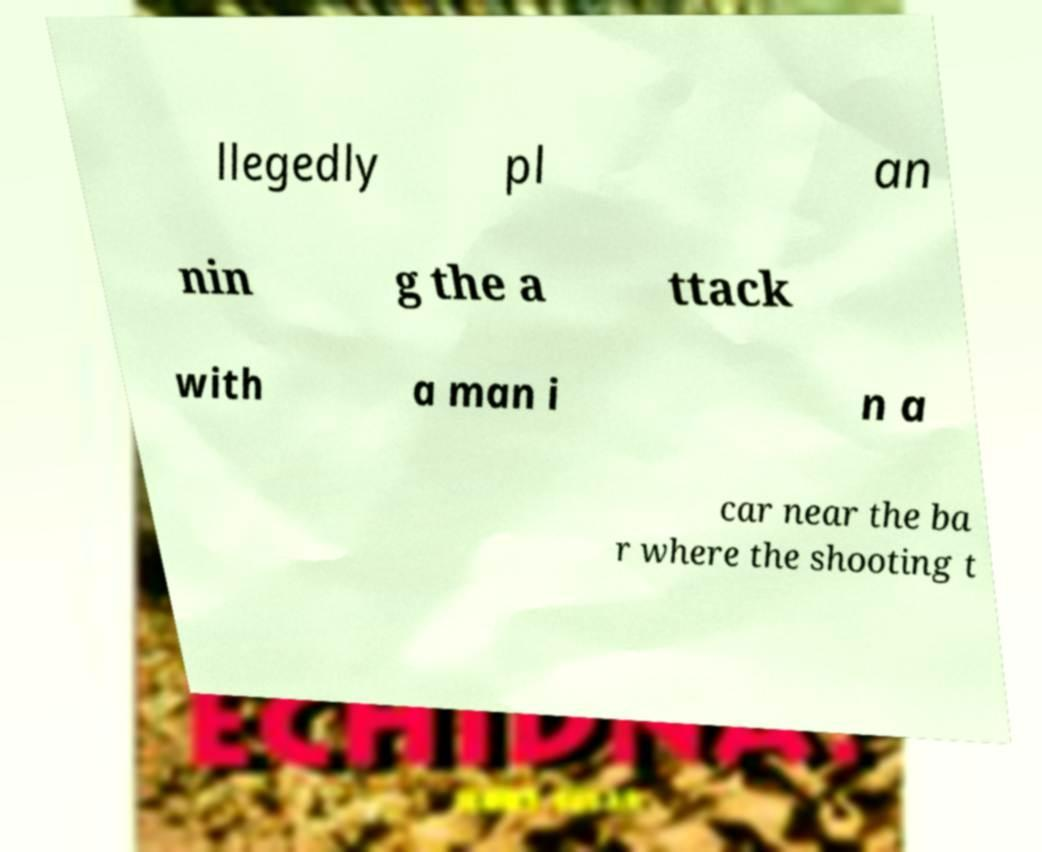For documentation purposes, I need the text within this image transcribed. Could you provide that? llegedly pl an nin g the a ttack with a man i n a car near the ba r where the shooting t 